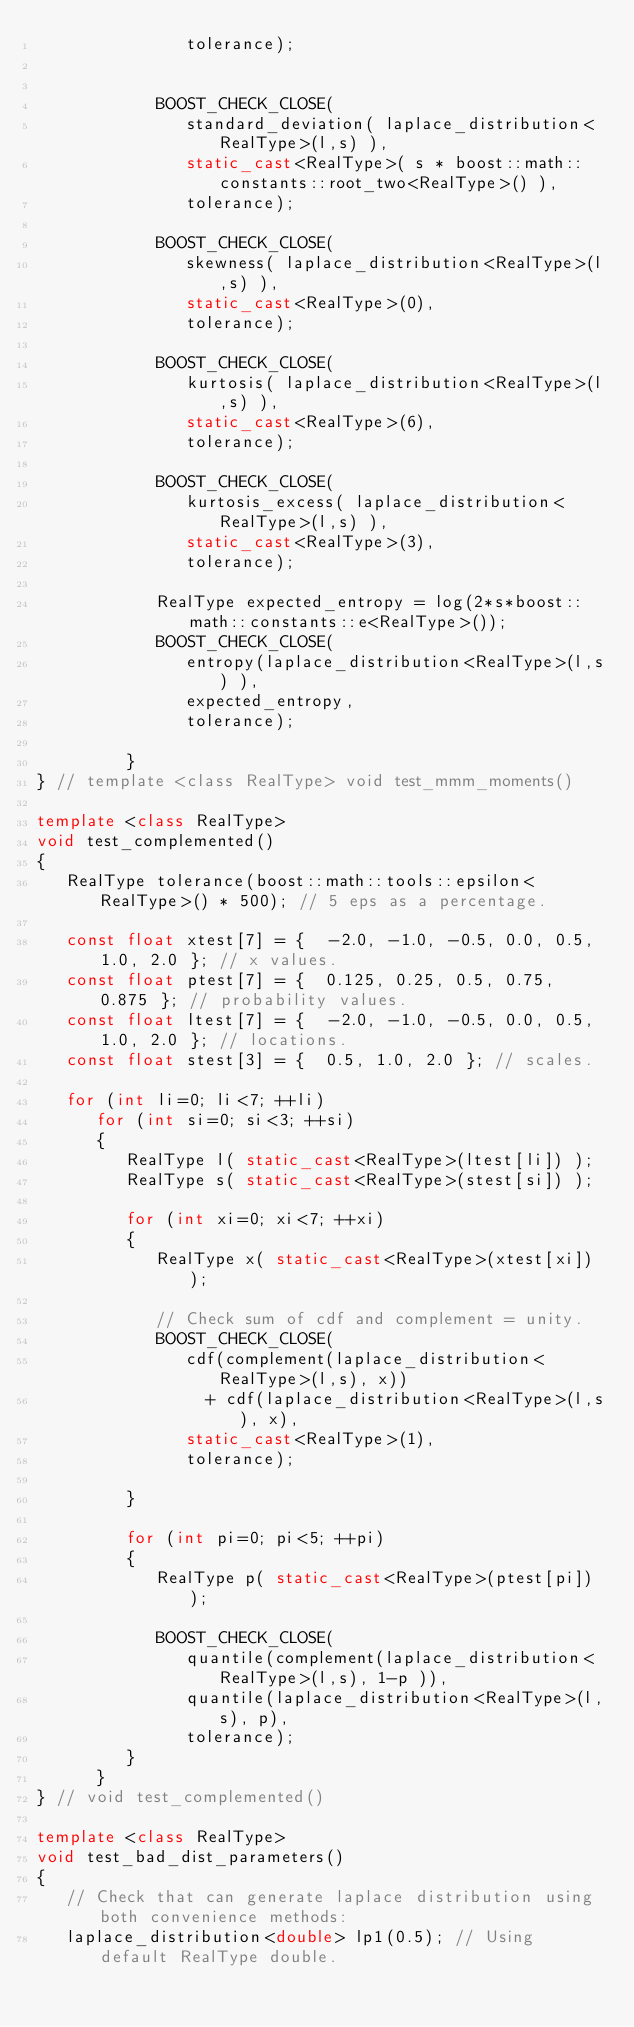Convert code to text. <code><loc_0><loc_0><loc_500><loc_500><_C++_>               tolerance);


            BOOST_CHECK_CLOSE( 
               standard_deviation( laplace_distribution<RealType>(l,s) ),
               static_cast<RealType>( s * boost::math::constants::root_two<RealType>() ),
               tolerance);

            BOOST_CHECK_CLOSE( 
               skewness( laplace_distribution<RealType>(l,s) ),
               static_cast<RealType>(0),
               tolerance);

            BOOST_CHECK_CLOSE( 
               kurtosis( laplace_distribution<RealType>(l,s) ),
               static_cast<RealType>(6),
               tolerance);

            BOOST_CHECK_CLOSE( 
               kurtosis_excess( laplace_distribution<RealType>(l,s) ),
               static_cast<RealType>(3),
               tolerance);

            RealType expected_entropy = log(2*s*boost::math::constants::e<RealType>());
            BOOST_CHECK_CLOSE(
               entropy(laplace_distribution<RealType>(l,s) ),
               expected_entropy,
               tolerance);

         }
} // template <class RealType> void test_mmm_moments()

template <class RealType>
void test_complemented()
{
   RealType tolerance(boost::math::tools::epsilon<RealType>() * 500); // 5 eps as a percentage.

   const float xtest[7] = {  -2.0, -1.0, -0.5, 0.0, 0.5, 1.0, 2.0 }; // x values.
   const float ptest[7] = {  0.125, 0.25, 0.5, 0.75, 0.875 }; // probability values.
   const float ltest[7] = {  -2.0, -1.0, -0.5, 0.0, 0.5, 1.0, 2.0 }; // locations.
   const float stest[3] = {  0.5, 1.0, 2.0 }; // scales.

   for (int li=0; li<7; ++li)
      for (int si=0; si<3; ++si)
      {
         RealType l( static_cast<RealType>(ltest[li]) );
         RealType s( static_cast<RealType>(stest[si]) );

         for (int xi=0; xi<7; ++xi)
         {
            RealType x( static_cast<RealType>(xtest[xi]) );

            // Check sum of cdf and complement = unity.
            BOOST_CHECK_CLOSE( 
               cdf(complement(laplace_distribution<RealType>(l,s), x))
                 + cdf(laplace_distribution<RealType>(l,s), x),
               static_cast<RealType>(1),
               tolerance);

         }

         for (int pi=0; pi<5; ++pi)
         {
            RealType p( static_cast<RealType>(ptest[pi]) );

            BOOST_CHECK_CLOSE( 
               quantile(complement(laplace_distribution<RealType>(l,s), 1-p )), 
               quantile(laplace_distribution<RealType>(l,s), p),
               tolerance);
         }
      }
} // void test_complemented()

template <class RealType>
void test_bad_dist_parameters()
{
   // Check that can generate laplace distribution using both convenience methods:
   laplace_distribution<double> lp1(0.5); // Using default RealType double.</code> 